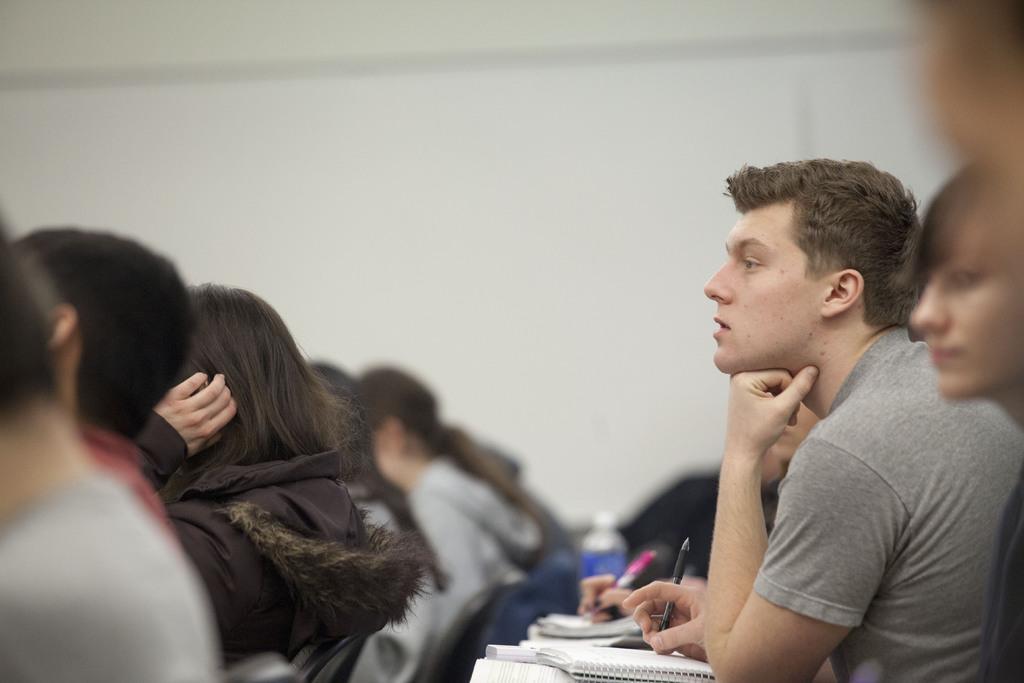Describe this image in one or two sentences. In this image I can see many people are sitting on the chairs facing towards left side. They are holding pens in the hands and writing on the books. In the background there is a wall. 